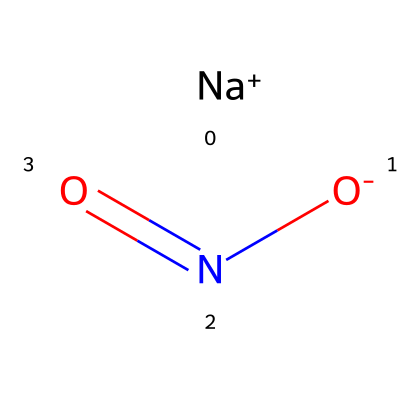What is the molecular formula of this chemical? By examining the structure represented by the SMILES notation, we can identify the different elements present: one sodium (Na) atom, one nitrogen (N) atom, and two oxygen (O) atoms. This gives us a molecular formula of NaNO2.
Answer: NaNO2 How many oxygen atoms are present in this molecule? From the SMILES representation, we see two oxygen atoms denoted by "O" in the structure, indicating that there are two oxygen atoms in this molecule.
Answer: 2 What is the charge of the sodium ion in this chemical? In the SMILES, the sodium is represented as [Na+], indicating that it carries a positive charge. Therefore, the sodium ion has a charge of +1.
Answer: +1 What is the primary functional group present in this compound? Analyzing the structure reveals the presence of a nitro group (-NO2) which is characteristic of nitrites; thus, the primary functional group in this compound is the nitrite group.
Answer: nitrite group What role does this molecule play in processed meats? This molecule, sodium nitrite, is commonly used as a preservative in processed meats due to its ability to inhibit bacterial growth and enhance color and flavor.
Answer: preservative How many valence electrons are associated with the nitrogen atom in this compound? The nitrogen atom in the nitrite group typically has five valence electrons; however, because it forms bonds with two oxygen atoms, it will effectively have three valence electrons 'used' in the bonds.
Answer: 5 